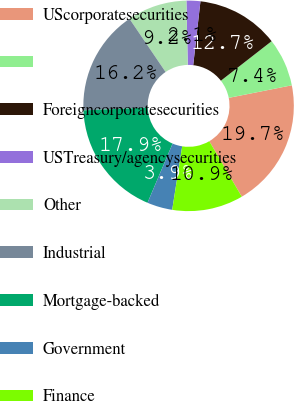Convert chart to OTSL. <chart><loc_0><loc_0><loc_500><loc_500><pie_chart><fcel>UScorporatesecurities<fcel>Unnamed: 1<fcel>Foreigncorporatesecurities<fcel>USTreasury/agencysecurities<fcel>Other<fcel>Industrial<fcel>Mortgage-backed<fcel>Government<fcel>Finance<nl><fcel>19.7%<fcel>7.4%<fcel>12.67%<fcel>2.13%<fcel>9.16%<fcel>16.19%<fcel>17.94%<fcel>3.89%<fcel>10.92%<nl></chart> 